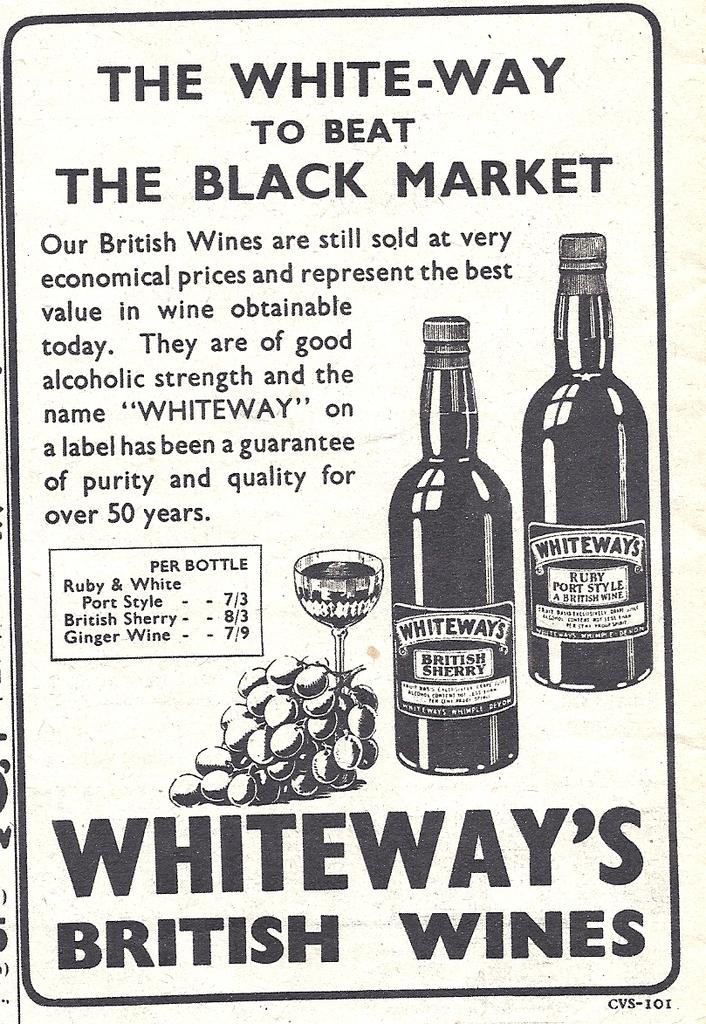What type of wines are being advertised?
Your response must be concise. British wines. What does it beat?
Give a very brief answer. The black market. 